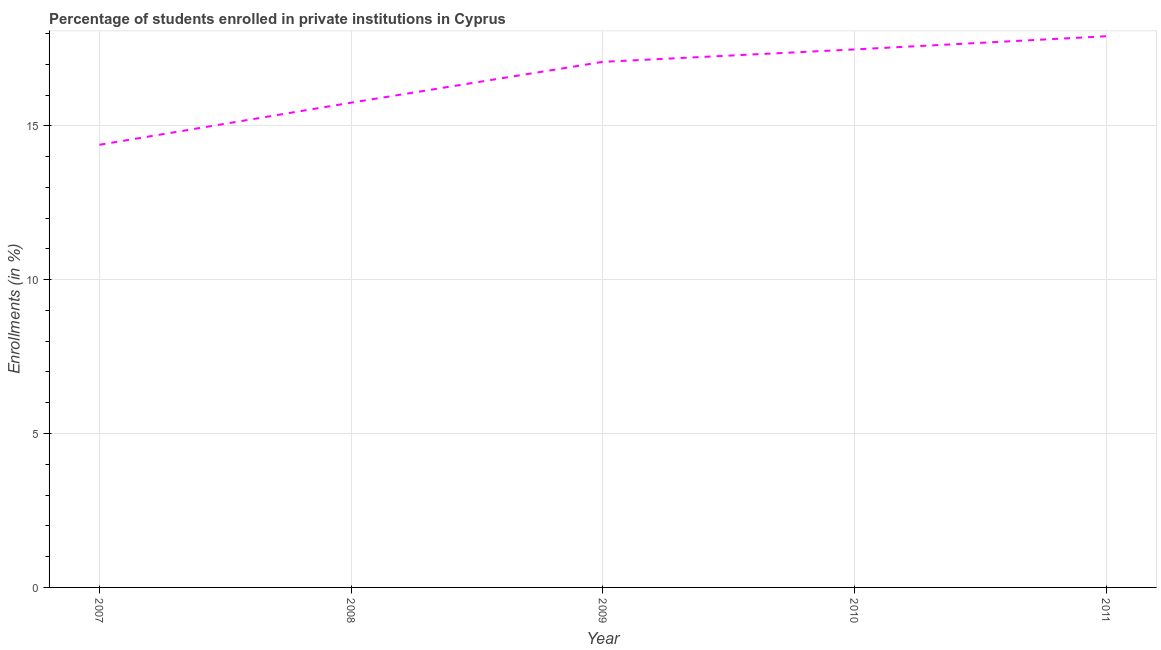What is the enrollments in private institutions in 2009?
Provide a short and direct response. 17.08. Across all years, what is the maximum enrollments in private institutions?
Offer a very short reply. 17.91. Across all years, what is the minimum enrollments in private institutions?
Make the answer very short. 14.38. In which year was the enrollments in private institutions maximum?
Offer a very short reply. 2011. In which year was the enrollments in private institutions minimum?
Provide a short and direct response. 2007. What is the sum of the enrollments in private institutions?
Give a very brief answer. 82.6. What is the difference between the enrollments in private institutions in 2008 and 2011?
Your answer should be compact. -2.16. What is the average enrollments in private institutions per year?
Offer a terse response. 16.52. What is the median enrollments in private institutions?
Keep it short and to the point. 17.08. Do a majority of the years between 2009 and 2011 (inclusive) have enrollments in private institutions greater than 15 %?
Your answer should be compact. Yes. What is the ratio of the enrollments in private institutions in 2008 to that in 2011?
Your answer should be compact. 0.88. What is the difference between the highest and the second highest enrollments in private institutions?
Provide a short and direct response. 0.43. What is the difference between the highest and the lowest enrollments in private institutions?
Provide a short and direct response. 3.53. In how many years, is the enrollments in private institutions greater than the average enrollments in private institutions taken over all years?
Give a very brief answer. 3. Are the values on the major ticks of Y-axis written in scientific E-notation?
Your answer should be very brief. No. Does the graph contain grids?
Give a very brief answer. Yes. What is the title of the graph?
Keep it short and to the point. Percentage of students enrolled in private institutions in Cyprus. What is the label or title of the X-axis?
Provide a short and direct response. Year. What is the label or title of the Y-axis?
Provide a short and direct response. Enrollments (in %). What is the Enrollments (in %) of 2007?
Provide a succinct answer. 14.38. What is the Enrollments (in %) in 2008?
Keep it short and to the point. 15.75. What is the Enrollments (in %) of 2009?
Ensure brevity in your answer.  17.08. What is the Enrollments (in %) in 2010?
Make the answer very short. 17.48. What is the Enrollments (in %) in 2011?
Ensure brevity in your answer.  17.91. What is the difference between the Enrollments (in %) in 2007 and 2008?
Provide a short and direct response. -1.37. What is the difference between the Enrollments (in %) in 2007 and 2009?
Ensure brevity in your answer.  -2.69. What is the difference between the Enrollments (in %) in 2007 and 2010?
Give a very brief answer. -3.1. What is the difference between the Enrollments (in %) in 2007 and 2011?
Offer a very short reply. -3.53. What is the difference between the Enrollments (in %) in 2008 and 2009?
Offer a very short reply. -1.33. What is the difference between the Enrollments (in %) in 2008 and 2010?
Provide a short and direct response. -1.73. What is the difference between the Enrollments (in %) in 2008 and 2011?
Your answer should be compact. -2.16. What is the difference between the Enrollments (in %) in 2009 and 2010?
Your response must be concise. -0.4. What is the difference between the Enrollments (in %) in 2009 and 2011?
Make the answer very short. -0.83. What is the difference between the Enrollments (in %) in 2010 and 2011?
Ensure brevity in your answer.  -0.43. What is the ratio of the Enrollments (in %) in 2007 to that in 2008?
Your answer should be very brief. 0.91. What is the ratio of the Enrollments (in %) in 2007 to that in 2009?
Your answer should be compact. 0.84. What is the ratio of the Enrollments (in %) in 2007 to that in 2010?
Your answer should be very brief. 0.82. What is the ratio of the Enrollments (in %) in 2007 to that in 2011?
Ensure brevity in your answer.  0.8. What is the ratio of the Enrollments (in %) in 2008 to that in 2009?
Give a very brief answer. 0.92. What is the ratio of the Enrollments (in %) in 2008 to that in 2010?
Offer a terse response. 0.9. What is the ratio of the Enrollments (in %) in 2008 to that in 2011?
Keep it short and to the point. 0.88. What is the ratio of the Enrollments (in %) in 2009 to that in 2011?
Your response must be concise. 0.95. What is the ratio of the Enrollments (in %) in 2010 to that in 2011?
Make the answer very short. 0.98. 